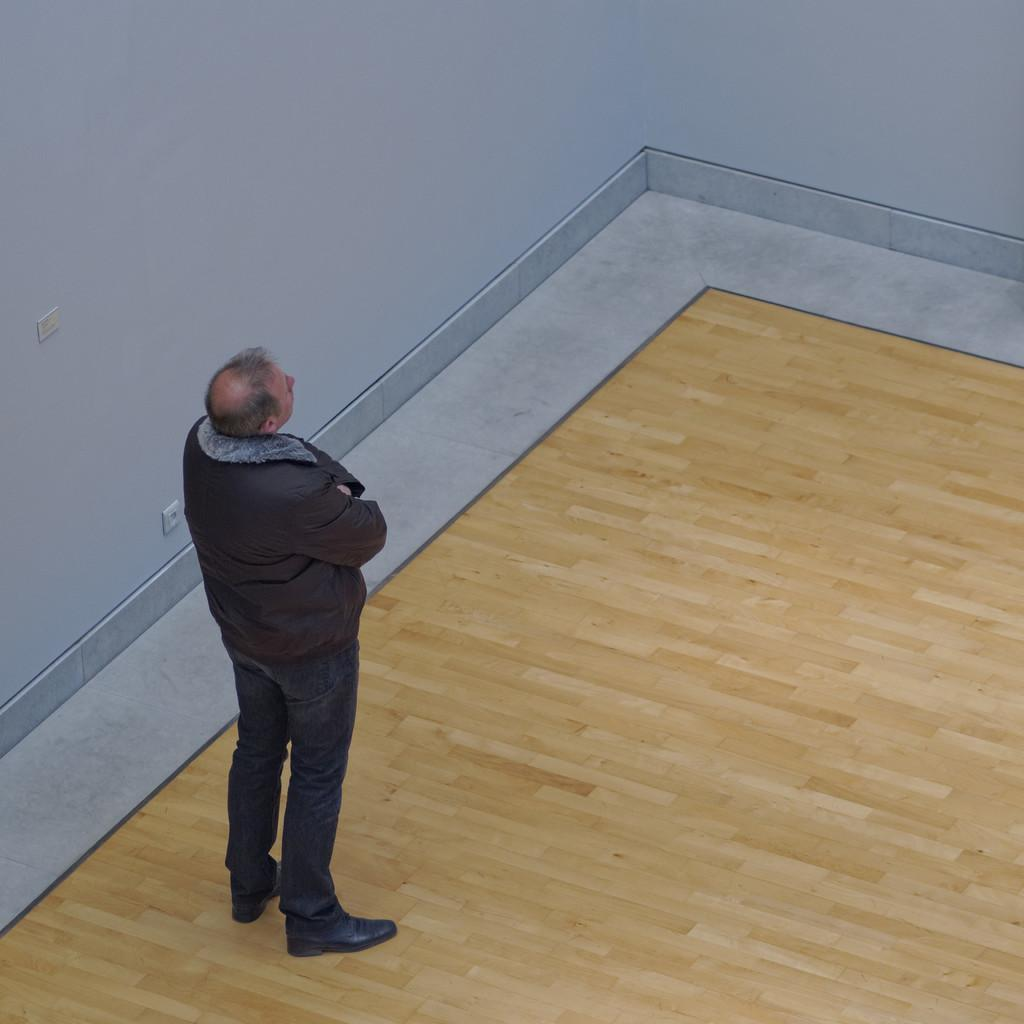What is the main subject of the image? There is a man standing in the image. What is the man doing in the image? The man is looking at something. What type of flooring is visible at the bottom of the image? There is a wooden floor at the bottom of the image. What type of footwear is the man wearing? The man is wearing shoes. What can be seen in the background of the image? There is a wall in the background of the image. What type of silverware is the man holding in the image? There is no silverware present in the image; the man is not holding anything. Can you see any jellyfish in the image? No, there are no jellyfish present in the image. 